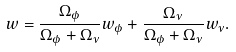<formula> <loc_0><loc_0><loc_500><loc_500>w = \frac { \Omega _ { \phi } } { \Omega _ { \phi } + \Omega _ { \nu } } w _ { \phi } + \frac { \Omega _ { \nu } } { \Omega _ { \phi } + \Omega _ { \nu } } w _ { \nu } .</formula> 